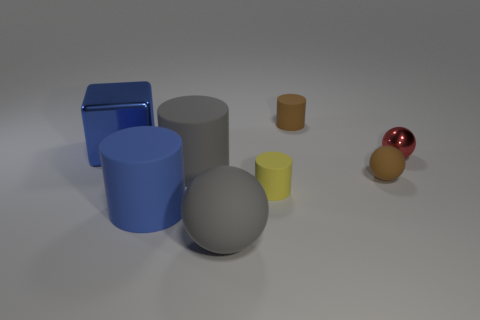Add 1 small brown cylinders. How many objects exist? 9 Subtract all spheres. How many objects are left? 5 Add 5 blue matte objects. How many blue matte objects exist? 6 Subtract 0 green balls. How many objects are left? 8 Subtract all big green metal objects. Subtract all small yellow cylinders. How many objects are left? 7 Add 2 blue matte objects. How many blue matte objects are left? 3 